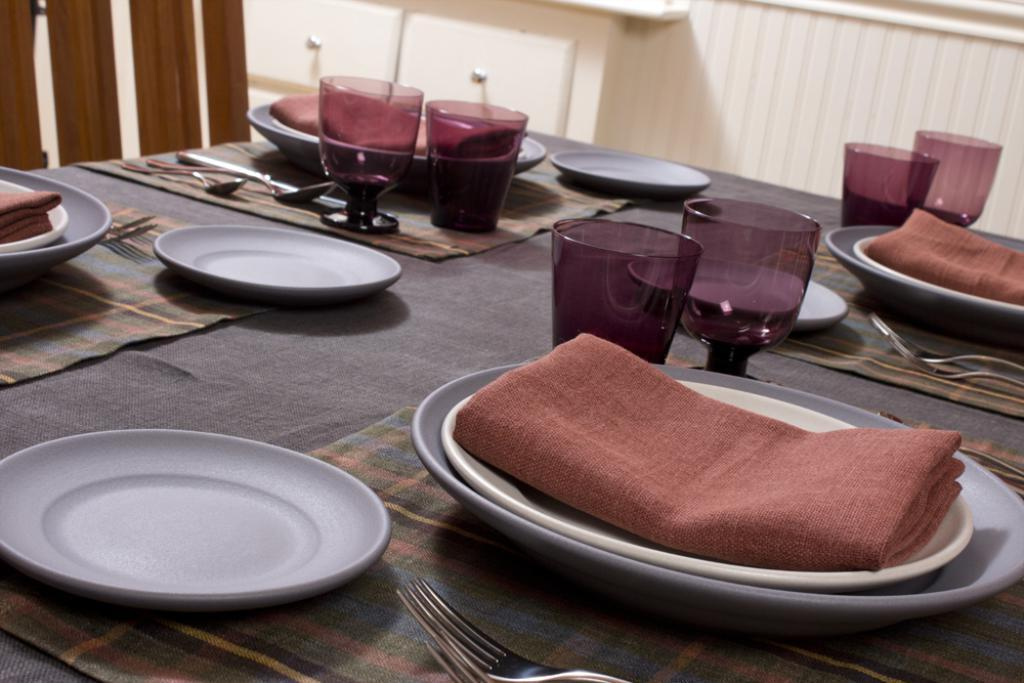What type of objects can be seen on the table in the image? There are plates, chairs, and spoons on the table in the image. What might be used for eating or serving food in the image? The spoons and plates can be used for eating or serving food. What are the chairs used for in the image? The chairs are likely used for sitting while eating or using the table. How does the cream spread on the table in the image? There is no cream present in the image, so it cannot spread on the table. 